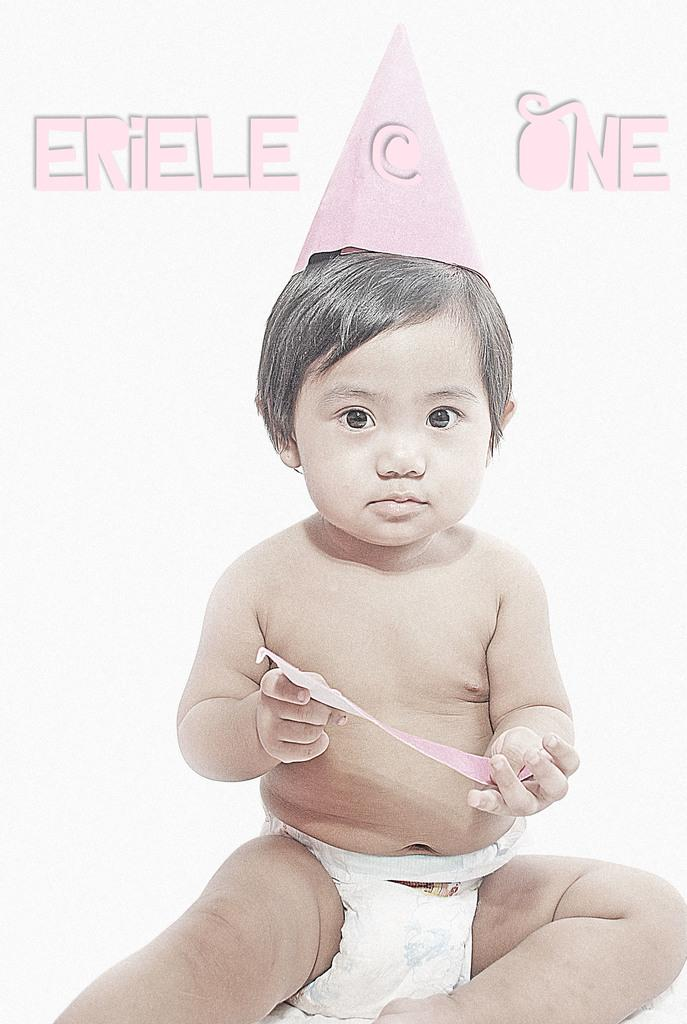What is the main subject of the image? There is a baby in the image. Can you describe the baby's attire? The baby is wearing a pink hat. What is the baby holding in the image? The baby is holding something. What color is the background of the image? The background of the image is white. Is there any text or writing in the image? Yes, there is pink writing in the image. How many stars can be seen in the image? There are no stars visible in the image. What type of bun is the baby holding in the image? The baby is not holding a bun in the image; they are holding something else. 